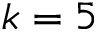Convert formula to latex. <formula><loc_0><loc_0><loc_500><loc_500>k = 5</formula> 